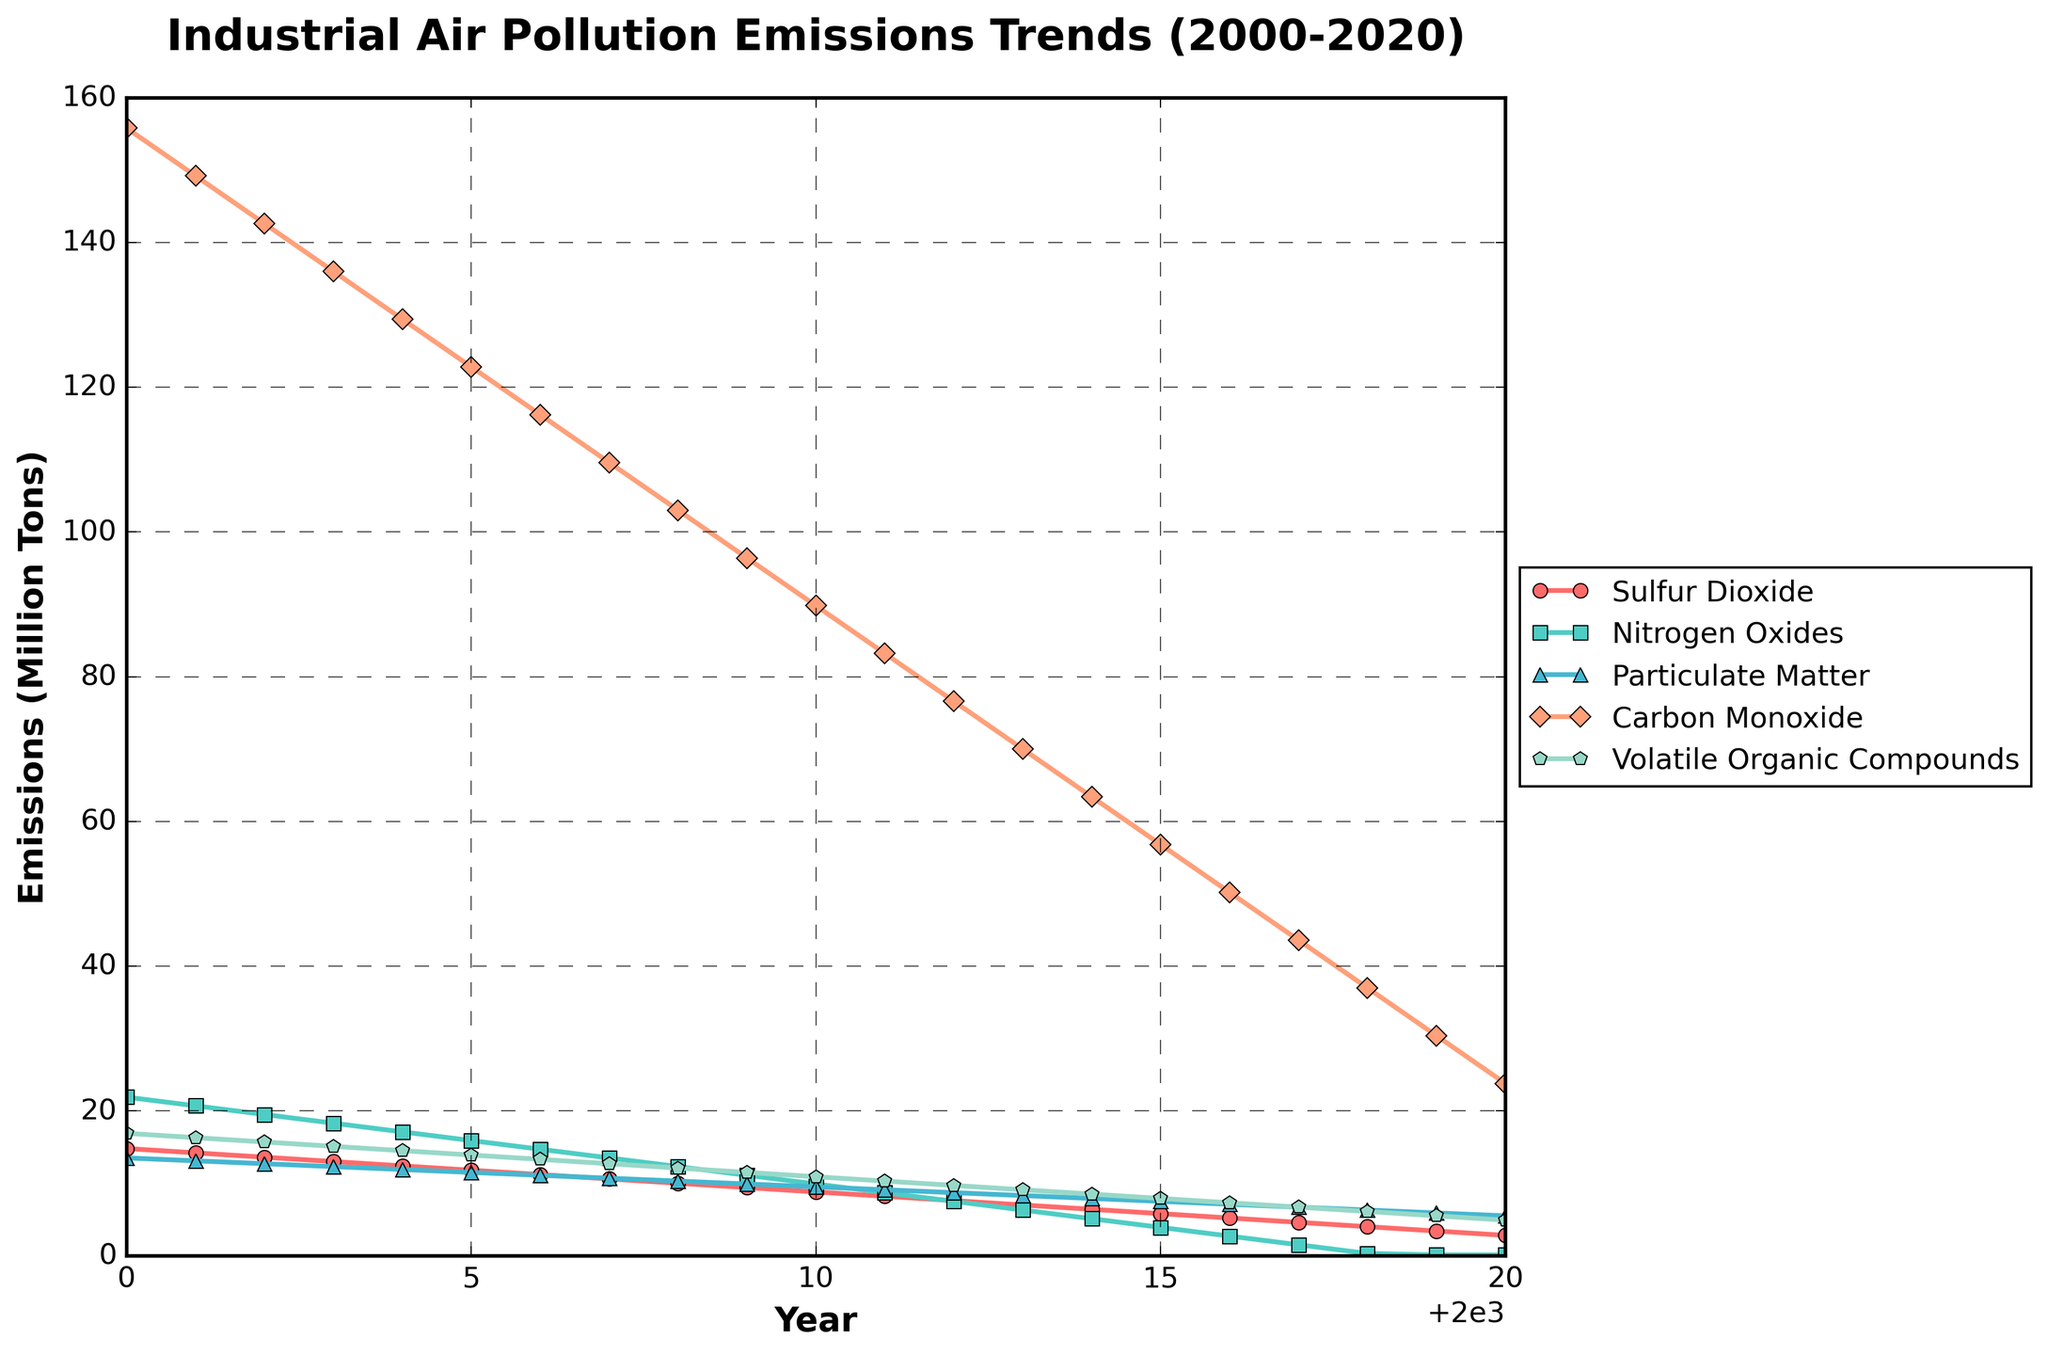What are the emission trends for Carbon Monoxide from 2000 to 2020? The emissions of Carbon Monoxide (CO) show a steady decreasing trend over the years from 155.8 million tons in 2000 to 23.8 million tons in 2020. The downward trend is consistent throughout the 20-year period.
Answer: Steady decrease Which pollutant had the highest emissions in the year 2005? By inspecting the figure for the year 2005, Carbon Monoxide (CO) has the highest emissions compared to other pollutants, as its line is positioned highest on the y-axis.
Answer: Carbon Monoxide In 2019, how does the emission level of Sulfur Dioxide compare to Nitrogen Oxides? In 2019, the emission level of Sulfur Dioxide is significantly higher than that of Nitrogen Oxides. Sulfur Dioxide emissions are at 3.4 million tons, while Nitrogen Oxides emissions are close to zero.
Answer: Sulfur Dioxide is higher What is the total emission reduction of Particulate Matter from 2000 to 2020? From the figure, Particulate Matter emissions decreased from 13.5 million tons in 2000 to 5.5 million tons in 2020. The total reduction is calculated as 13.5 - 5.5 = 8 million tons.
Answer: 8 million tons Which pollutant shows the steepest decline rate between 2010 and 2015? Observing the slopes of the lines between 2010 and 2015, Nitrogen Oxides show the steepest decline, decreasing from 9.9 million tons in 2010 to 3.9 million tons in 2015. Other pollutants decrease at a slower rate.
Answer: Nitrogen Oxides What is the average annual decrease in Carbon Monoxide emissions from 2000 to 2020? The difference in Carbon Monoxide emissions between 2000 and 2020 is 155.8 - 23.8 = 132 million tons. Over 20 years, the average annual decrease is calculated as 132/20 = 6.6 million tons per year.
Answer: 6.6 million tons per year Which pollutant has the lowest emissions in 2020, and what is the level? In 2020, Nitrogen Oxides have the lowest emissions, as their line is closest to the x-axis, showing an emission level of nearly 0.1 million tons.
Answer: Nitrogen Oxides, 0.1 million tons How do the emission trends of Volatile Organic Compounds and Particulate Matter compare from 2000 to 2020? Both pollutants show a decreasing trend, but Volatile Organic Compounds (VOC) started at a higher value in 2000 (16.9 million tons) and ended at a lower value in 2020 (4.9 million tons) compared to Particulate Matter, which started at 13.5 million tons and ended at 5.5 million tons. The decline in VOC is more pronounced.
Answer: VOC shows a steeper decline than Particulate Matter 